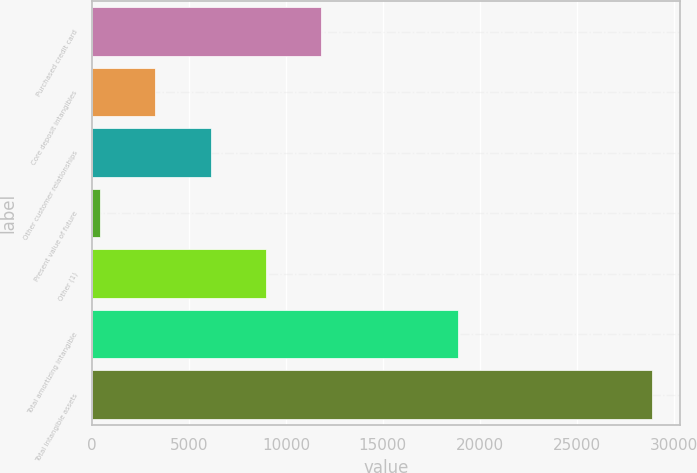<chart> <loc_0><loc_0><loc_500><loc_500><bar_chart><fcel>Purchased credit card<fcel>Core deposit intangibles<fcel>Other customer relationships<fcel>Present value of future<fcel>Other (1)<fcel>Total amortizing intangible<fcel>Total intangible assets<nl><fcel>11800.6<fcel>3270.4<fcel>6113.8<fcel>427<fcel>8957.2<fcel>18890<fcel>28861<nl></chart> 